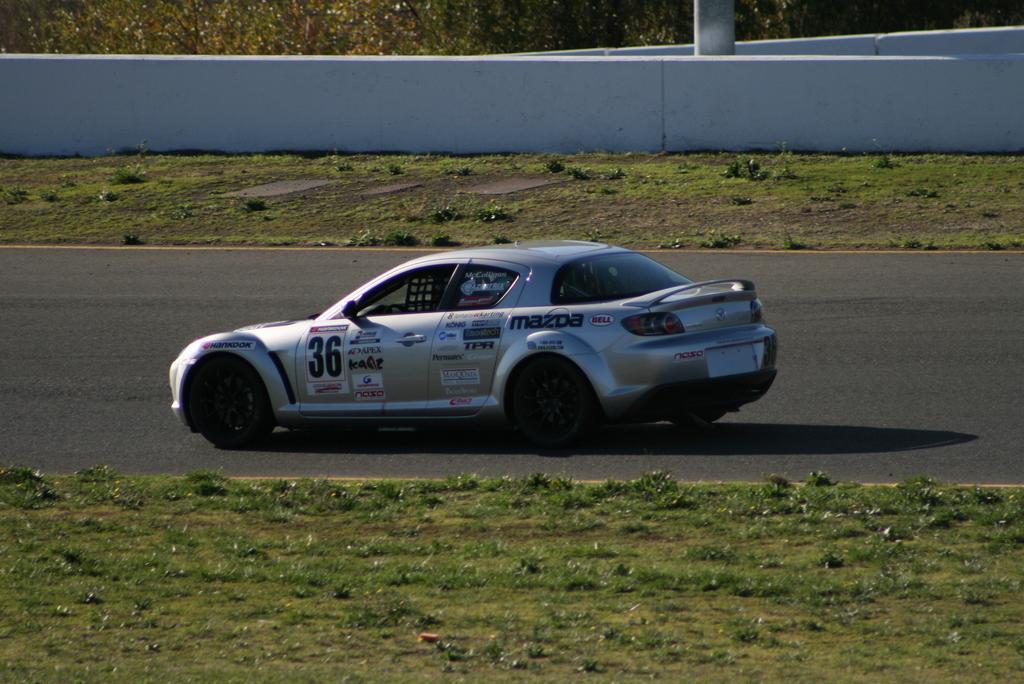Can you describe this image briefly? In this image there is a car on the road beside that there is grass, fence wall, pole and trees. 